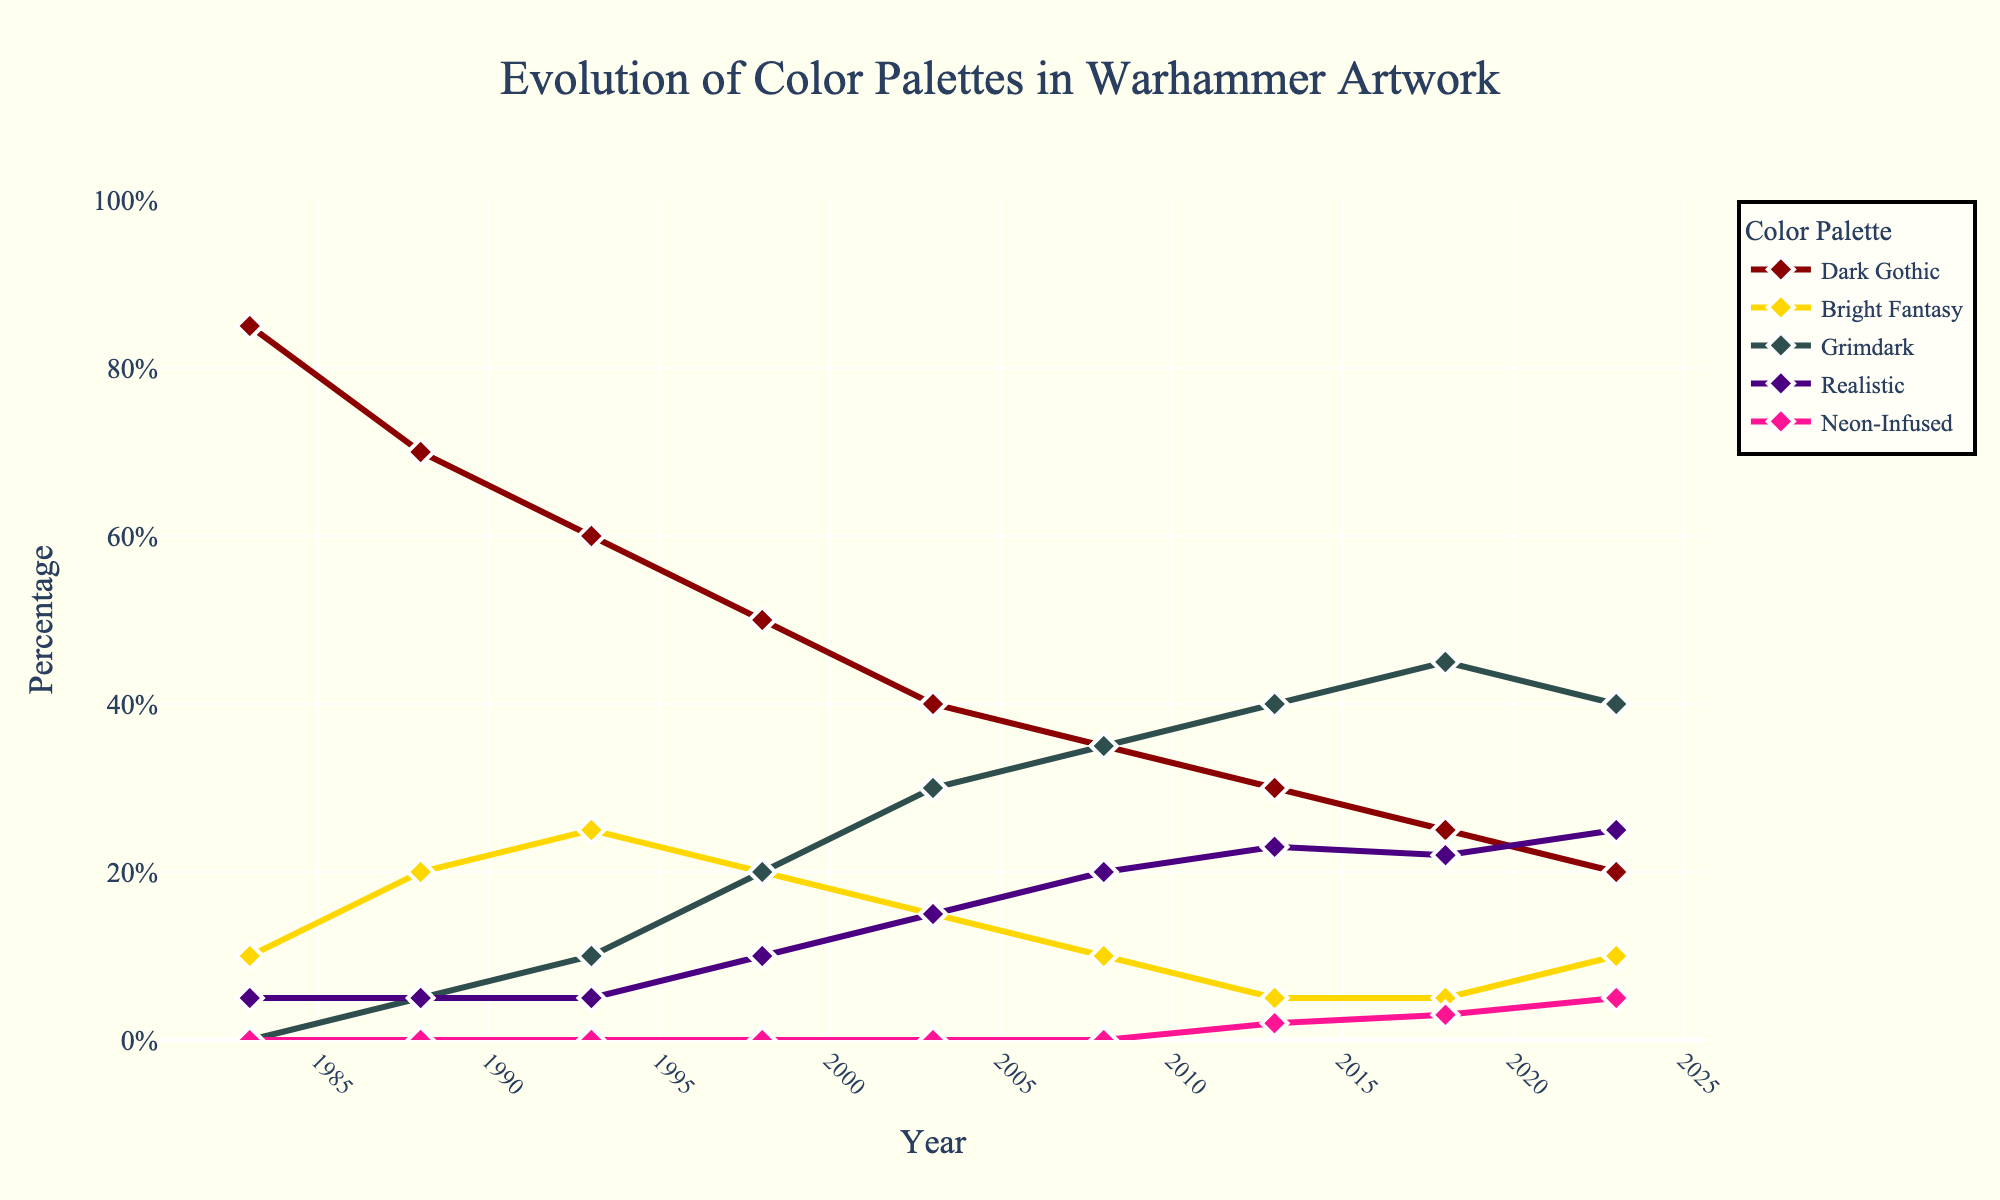What color palette became more dominant around 2003 compared to the 80s? From the figure, observe the trends in the color palettes over the years. The Grimdark palette shows a sharp increase around 2003 compared to the 1980s, rising from 0% in 1983 to about 30% in 2003.
Answer: Grimdark By 2023, which color palette had the highest percentage usage? Checking the figure for 2023 and comparing the different color palette lines, we see that the Grimdark palette represents around 40%, which is the highest among all palettes.
Answer: Grimdark Which color palette has been declining since the 1980s? Looking at the figure, the Dark Gothic palette starts high in the 1980s and consistently declines over time, dropping from 85% in 1983 to 20% in 2023.
Answer: Dark Gothic What is the difference in percentage usage between Realistic and Neon-Infused palettes in 2023? Locate the usage percentages for Realistic and Neon-Infused palettes in 2023. Realistic is at 25%, and Neon-Infused is at 5%. The difference is calculated as 25% - 5%.
Answer: 20% Which two color palettes had the closest percentage usage in 2018? Inspect the 2018 values for all palettes. Bright Fantasy and Realistic both show nearly similar percentages, with around 5% for Bright Fantasy and 22% for Realistic.
Answer: Bright Fantasy and Realistic Describe the trend for the Bright Fantasy palette from 1983 to 2023. By following the Bright Fantasy line in the figure, it starts at 10% in 1983 and increases to 25% in 1993, then decreases steadily to 5% by 2013, with a slight rise to 10% in 2023.
Answer: Rising initially, then steadily declining Between 1998 and 2003, what was the rate of change in the percentage usage of the Grimdark palette? Identify the Grimdark percentages in 1998 and 2003, which are 20% and 30%, respectively. The rate of change is calculated as (30% - 20%) / (2003 - 1998) = 10% / 5 years = 2% per year.
Answer: 2% per year Which palette showed a new entry after 2008? Examine the lines in the figure and find the Neon-Infused palette, which appears from 2013 onwards, indicating its new entry post-2008.
Answer: Neon-Infused How does the usage of the Realistic palette in 2008 compare to 2023? Check the Realistic line for both 2008 and 2023. In 2008, Realistic is at 20%, and in 2023 it increases slightly to 25%.
Answer: Increased 